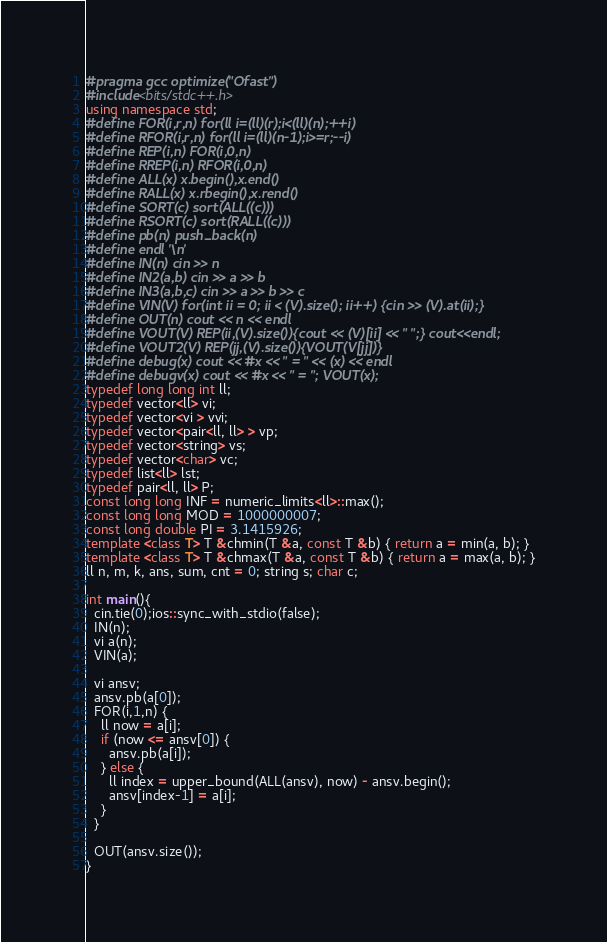<code> <loc_0><loc_0><loc_500><loc_500><_C++_>#pragma gcc optimize("Ofast")
#include<bits/stdc++.h>
using namespace std;
#define FOR(i,r,n) for(ll i=(ll)(r);i<(ll)(n);++i)
#define RFOR(i,r,n) for(ll i=(ll)(n-1);i>=r;--i)
#define REP(i,n) FOR(i,0,n)
#define RREP(i,n) RFOR(i,0,n)
#define ALL(x) x.begin(),x.end()
#define RALL(x) x.rbegin(),x.rend()
#define SORT(c) sort(ALL((c)))
#define RSORT(c) sort(RALL((c)))
#define pb(n) push_back(n)
#define endl '\n'
#define IN(n) cin >> n
#define IN2(a,b) cin >> a >> b
#define IN3(a,b,c) cin >> a >> b >> c
#define VIN(V) for(int ii = 0; ii < (V).size(); ii++) {cin >> (V).at(ii);}
#define OUT(n) cout << n << endl
#define VOUT(V) REP(ii,(V).size()){cout << (V)[ii] << " ";} cout<<endl;
#define VOUT2(V) REP(jj,(V).size()){VOUT(V[jj])}
#define debug(x) cout << #x << " = " << (x) << endl
#define debugv(x) cout << #x << " = "; VOUT(x);
typedef long long int ll;
typedef vector<ll> vi;
typedef vector<vi > vvi;
typedef vector<pair<ll, ll> > vp;
typedef vector<string> vs;
typedef vector<char> vc;
typedef list<ll> lst;
typedef pair<ll, ll> P;
const long long INF = numeric_limits<ll>::max();
const long long MOD = 1000000007;
const long double PI = 3.1415926;
template <class T> T &chmin(T &a, const T &b) { return a = min(a, b); }
template <class T> T &chmax(T &a, const T &b) { return a = max(a, b); }
ll n, m, k, ans, sum, cnt = 0; string s; char c;

int main(){
  cin.tie(0);ios::sync_with_stdio(false);
  IN(n);
  vi a(n);
  VIN(a);

  vi ansv;
  ansv.pb(a[0]);
  FOR(i,1,n) {
    ll now = a[i];
    if (now <= ansv[0]) {
      ansv.pb(a[i]);
    } else {
      ll index = upper_bound(ALL(ansv), now) - ansv.begin();
      ansv[index-1] = a[i];
    }
  }

  OUT(ansv.size());
}
</code> 